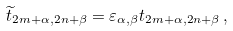<formula> <loc_0><loc_0><loc_500><loc_500>\widetilde { t } _ { 2 m + \alpha , 2 n + \beta } = \varepsilon _ { \alpha , \beta } t _ { 2 m + \alpha , 2 n + \beta } \, ,</formula> 